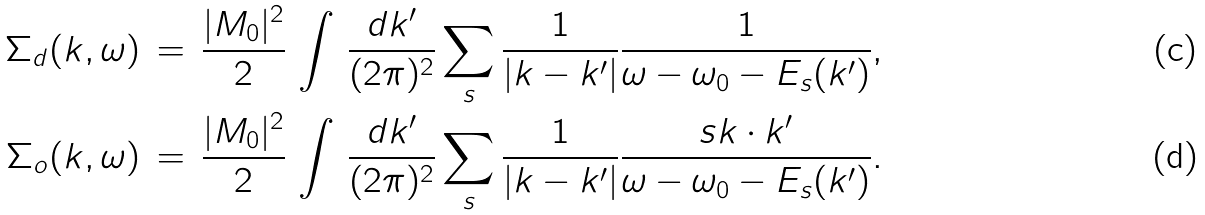Convert formula to latex. <formula><loc_0><loc_0><loc_500><loc_500>\Sigma _ { d } ( k , \omega ) & \, = \, \frac { | M _ { 0 } | ^ { 2 } } { 2 } \, \int \, \frac { d { k } ^ { \prime } } { ( 2 \pi ) ^ { 2 } } \sum _ { s } \frac { 1 } { | { k } - { k } ^ { \prime } | } \frac { 1 } { \omega - \omega _ { 0 } - E _ { s } ( k ^ { \prime } ) } , \\ \Sigma _ { o } ( k , \omega ) & \, = \, \frac { | M _ { 0 } | ^ { 2 } } { 2 } \, \int \, \frac { d { k } ^ { \prime } } { ( 2 \pi ) ^ { 2 } } \sum _ { s } \frac { 1 } { | { k } - { k } ^ { \prime } | } \frac { s { k } \cdot { k } ^ { \prime } } { \omega - \omega _ { 0 } - E _ { s } ( k ^ { \prime } ) } .</formula> 